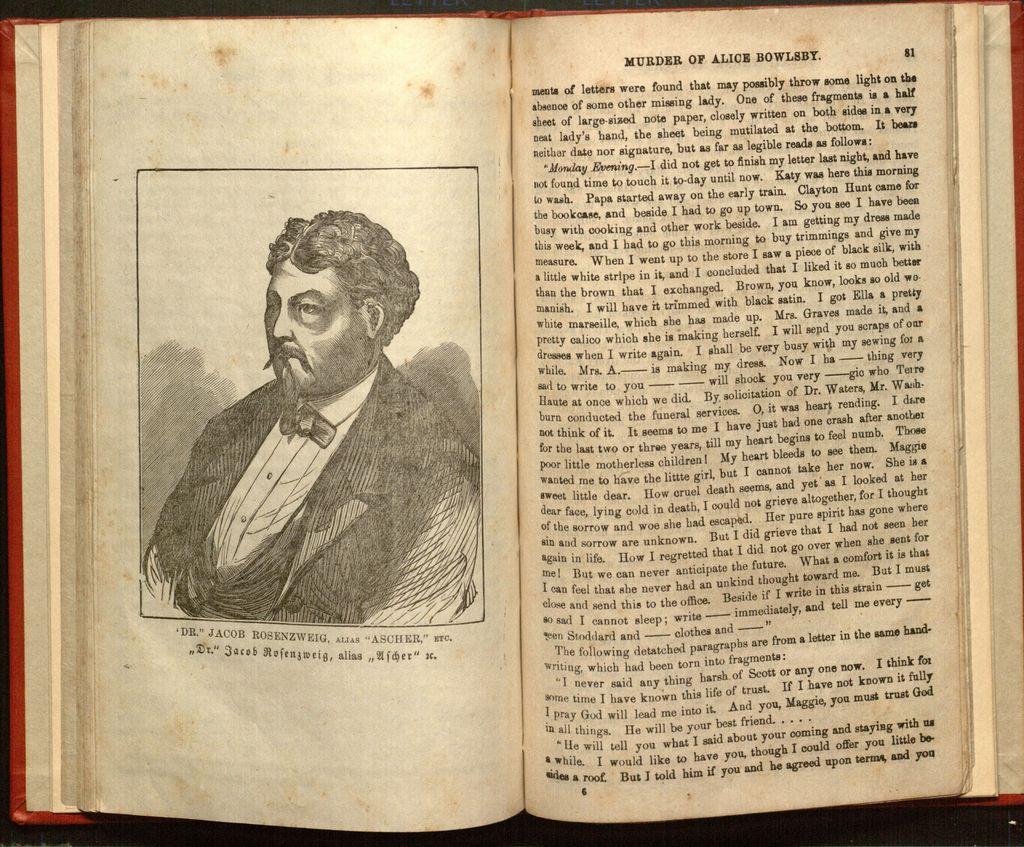What is the books title?
Offer a terse response. Murder of alice bowlsby. 